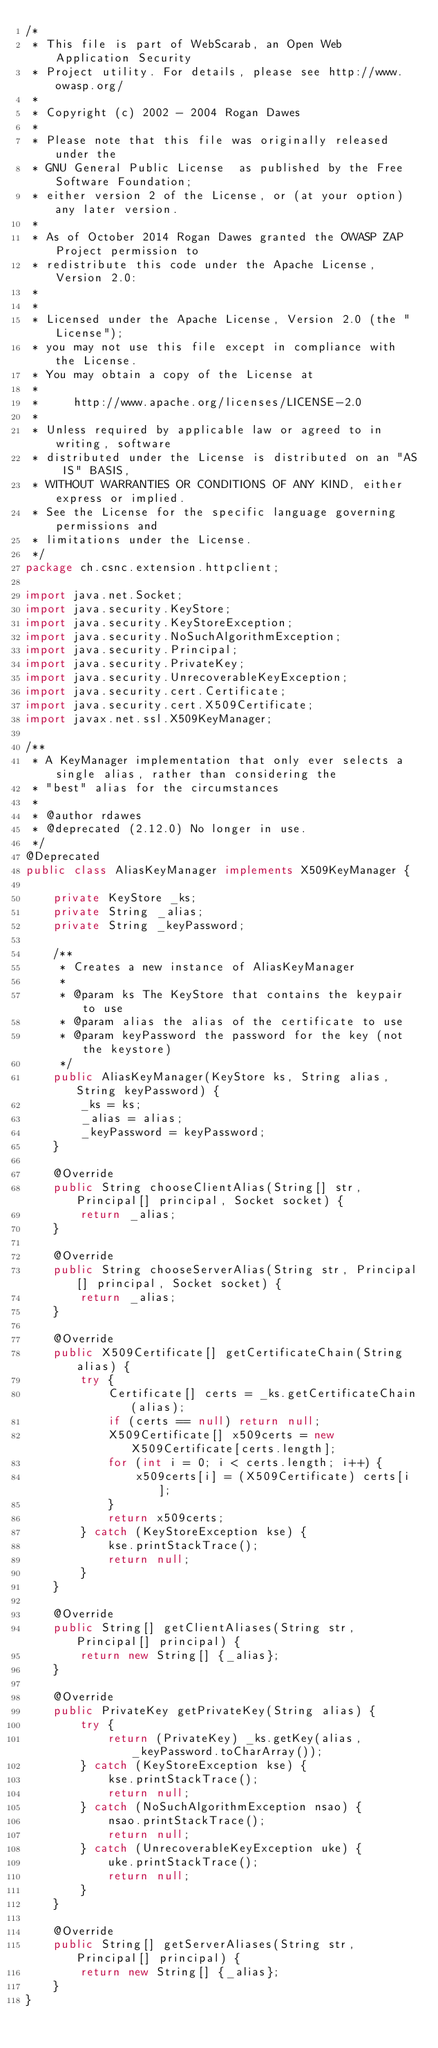Convert code to text. <code><loc_0><loc_0><loc_500><loc_500><_Java_>/*
 * This file is part of WebScarab, an Open Web Application Security
 * Project utility. For details, please see http://www.owasp.org/
 *
 * Copyright (c) 2002 - 2004 Rogan Dawes
 *
 * Please note that this file was originally released under the
 * GNU General Public License  as published by the Free Software Foundation;
 * either version 2 of the License, or (at your option) any later version.
 *
 * As of October 2014 Rogan Dawes granted the OWASP ZAP Project permission to
 * redistribute this code under the Apache License, Version 2.0:
 *
 *
 * Licensed under the Apache License, Version 2.0 (the "License");
 * you may not use this file except in compliance with the License.
 * You may obtain a copy of the License at
 *
 *     http://www.apache.org/licenses/LICENSE-2.0
 *
 * Unless required by applicable law or agreed to in writing, software
 * distributed under the License is distributed on an "AS IS" BASIS,
 * WITHOUT WARRANTIES OR CONDITIONS OF ANY KIND, either express or implied.
 * See the License for the specific language governing permissions and
 * limitations under the License.
 */
package ch.csnc.extension.httpclient;

import java.net.Socket;
import java.security.KeyStore;
import java.security.KeyStoreException;
import java.security.NoSuchAlgorithmException;
import java.security.Principal;
import java.security.PrivateKey;
import java.security.UnrecoverableKeyException;
import java.security.cert.Certificate;
import java.security.cert.X509Certificate;
import javax.net.ssl.X509KeyManager;

/**
 * A KeyManager implementation that only ever selects a single alias, rather than considering the
 * "best" alias for the circumstances
 *
 * @author rdawes
 * @deprecated (2.12.0) No longer in use.
 */
@Deprecated
public class AliasKeyManager implements X509KeyManager {

    private KeyStore _ks;
    private String _alias;
    private String _keyPassword;

    /**
     * Creates a new instance of AliasKeyManager
     *
     * @param ks The KeyStore that contains the keypair to use
     * @param alias the alias of the certificate to use
     * @param keyPassword the password for the key (not the keystore)
     */
    public AliasKeyManager(KeyStore ks, String alias, String keyPassword) {
        _ks = ks;
        _alias = alias;
        _keyPassword = keyPassword;
    }

    @Override
    public String chooseClientAlias(String[] str, Principal[] principal, Socket socket) {
        return _alias;
    }

    @Override
    public String chooseServerAlias(String str, Principal[] principal, Socket socket) {
        return _alias;
    }

    @Override
    public X509Certificate[] getCertificateChain(String alias) {
        try {
            Certificate[] certs = _ks.getCertificateChain(alias);
            if (certs == null) return null;
            X509Certificate[] x509certs = new X509Certificate[certs.length];
            for (int i = 0; i < certs.length; i++) {
                x509certs[i] = (X509Certificate) certs[i];
            }
            return x509certs;
        } catch (KeyStoreException kse) {
            kse.printStackTrace();
            return null;
        }
    }

    @Override
    public String[] getClientAliases(String str, Principal[] principal) {
        return new String[] {_alias};
    }

    @Override
    public PrivateKey getPrivateKey(String alias) {
        try {
            return (PrivateKey) _ks.getKey(alias, _keyPassword.toCharArray());
        } catch (KeyStoreException kse) {
            kse.printStackTrace();
            return null;
        } catch (NoSuchAlgorithmException nsao) {
            nsao.printStackTrace();
            return null;
        } catch (UnrecoverableKeyException uke) {
            uke.printStackTrace();
            return null;
        }
    }

    @Override
    public String[] getServerAliases(String str, Principal[] principal) {
        return new String[] {_alias};
    }
}
</code> 